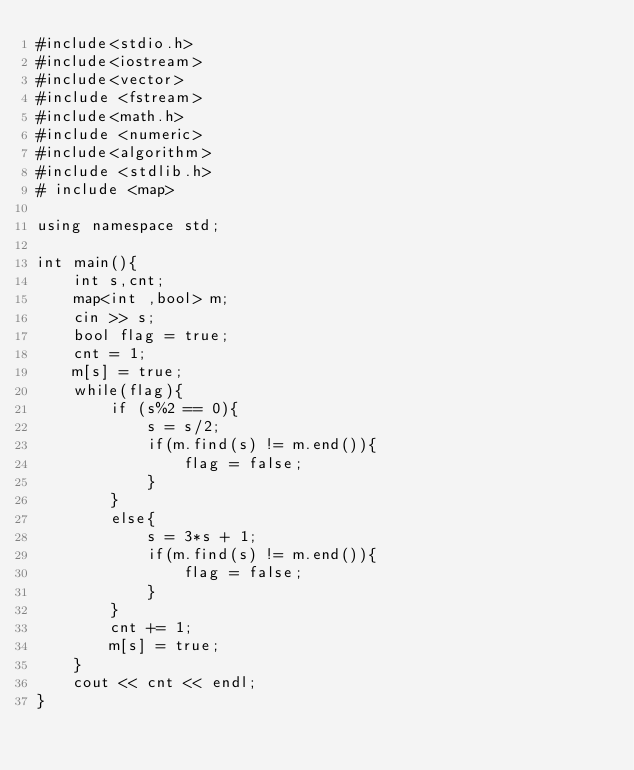Convert code to text. <code><loc_0><loc_0><loc_500><loc_500><_C++_>#include<stdio.h>
#include<iostream>
#include<vector>
#include <fstream>
#include<math.h>
#include <numeric>
#include<algorithm>
#include <stdlib.h>
# include <map>

using namespace std;

int main(){
    int s,cnt;
    map<int ,bool> m;
    cin >> s;
    bool flag = true;
    cnt = 1;
    m[s] = true;
    while(flag){
        if (s%2 == 0){
            s = s/2;
            if(m.find(s) != m.end()){
                flag = false;
            }
        }
        else{
            s = 3*s + 1;
            if(m.find(s) != m.end()){
                flag = false;
            }
        }
        cnt += 1;
        m[s] = true;
    }
    cout << cnt << endl;
}
</code> 